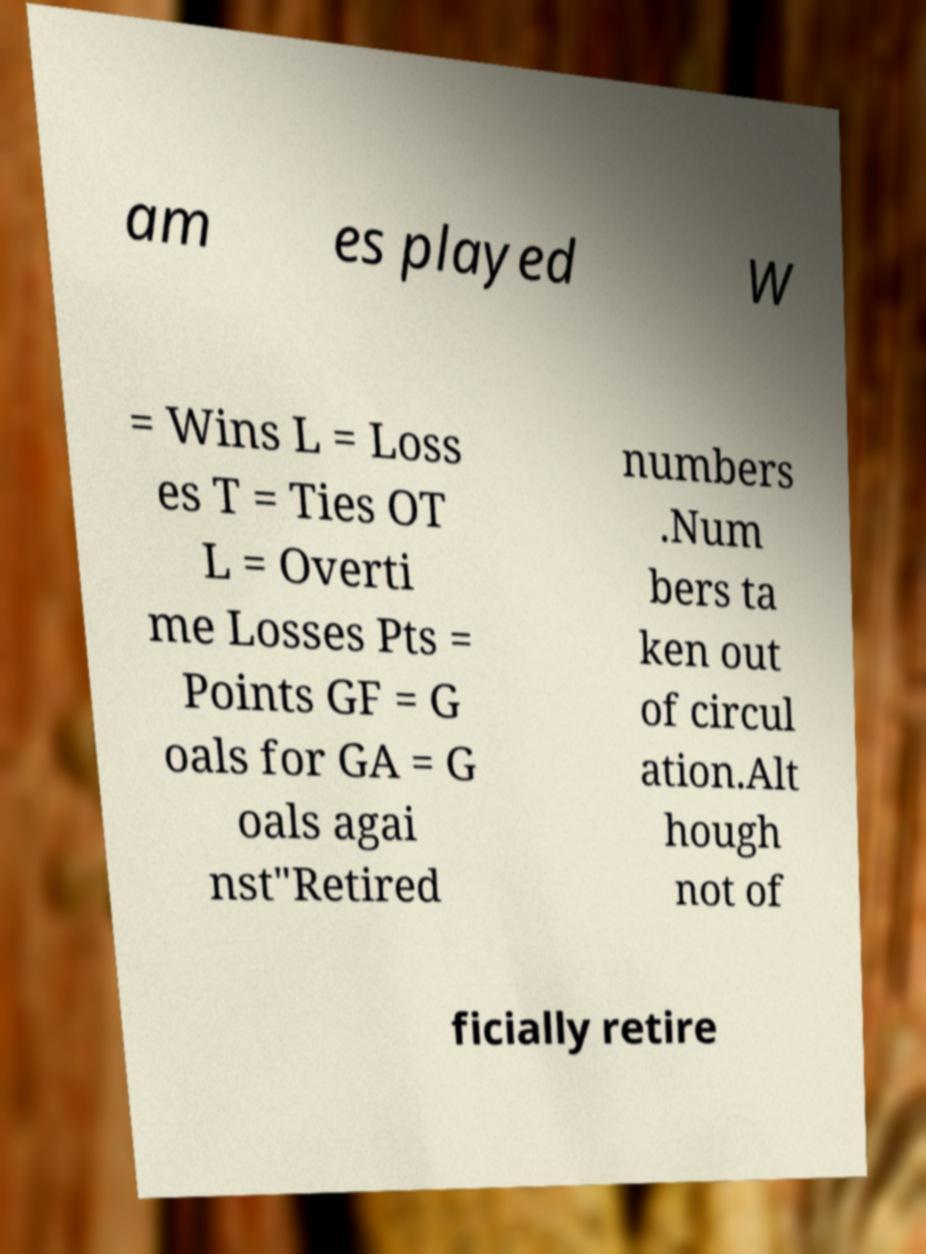There's text embedded in this image that I need extracted. Can you transcribe it verbatim? am es played W = Wins L = Loss es T = Ties OT L = Overti me Losses Pts = Points GF = G oals for GA = G oals agai nst"Retired numbers .Num bers ta ken out of circul ation.Alt hough not of ficially retire 